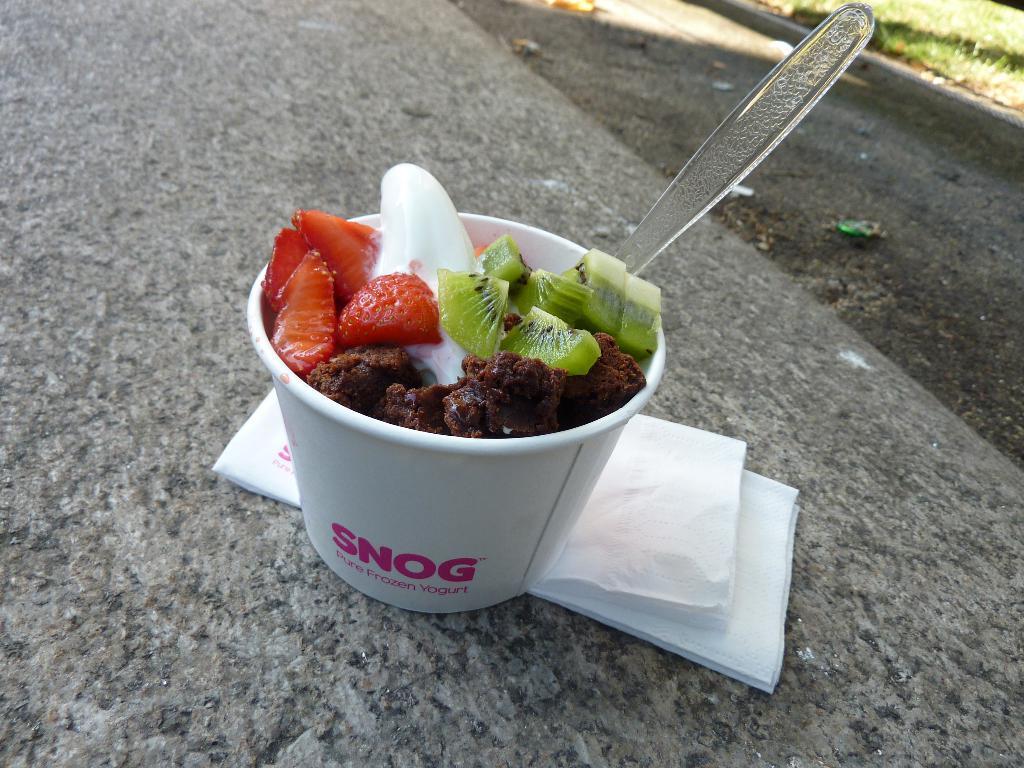Describe this image in one or two sentences. In this picture we can see there are fruits and a spoon in the paper cup. There are tissue papers and the paper cup on the ground. In the top right corner of the image, there is grass. 